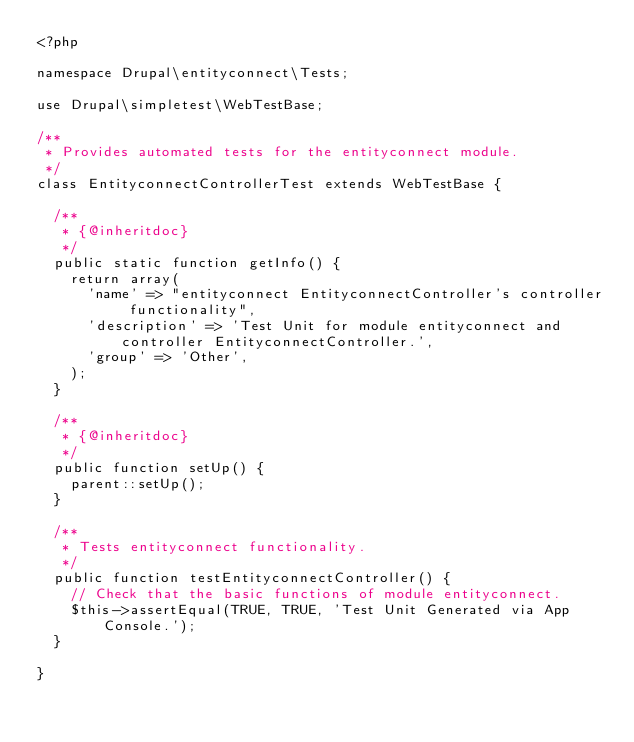<code> <loc_0><loc_0><loc_500><loc_500><_PHP_><?php

namespace Drupal\entityconnect\Tests;

use Drupal\simpletest\WebTestBase;

/**
 * Provides automated tests for the entityconnect module.
 */
class EntityconnectControllerTest extends WebTestBase {

  /**
   * {@inheritdoc}
   */
  public static function getInfo() {
    return array(
      'name' => "entityconnect EntityconnectController's controller functionality",
      'description' => 'Test Unit for module entityconnect and controller EntityconnectController.',
      'group' => 'Other',
    );
  }

  /**
   * {@inheritdoc}
   */
  public function setUp() {
    parent::setUp();
  }

  /**
   * Tests entityconnect functionality.
   */
  public function testEntityconnectController() {
    // Check that the basic functions of module entityconnect.
    $this->assertEqual(TRUE, TRUE, 'Test Unit Generated via App Console.');
  }

}
</code> 